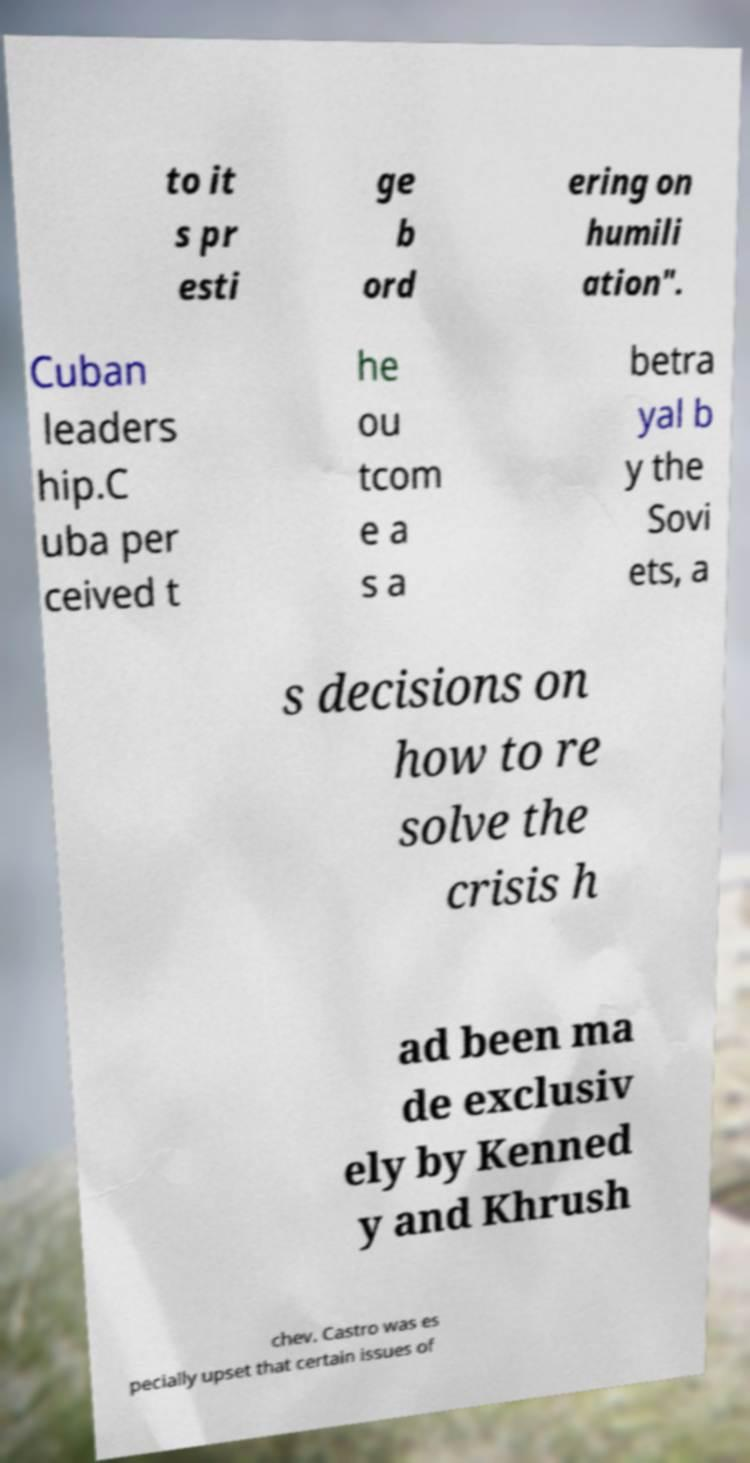For documentation purposes, I need the text within this image transcribed. Could you provide that? to it s pr esti ge b ord ering on humili ation". Cuban leaders hip.C uba per ceived t he ou tcom e a s a betra yal b y the Sovi ets, a s decisions on how to re solve the crisis h ad been ma de exclusiv ely by Kenned y and Khrush chev. Castro was es pecially upset that certain issues of 